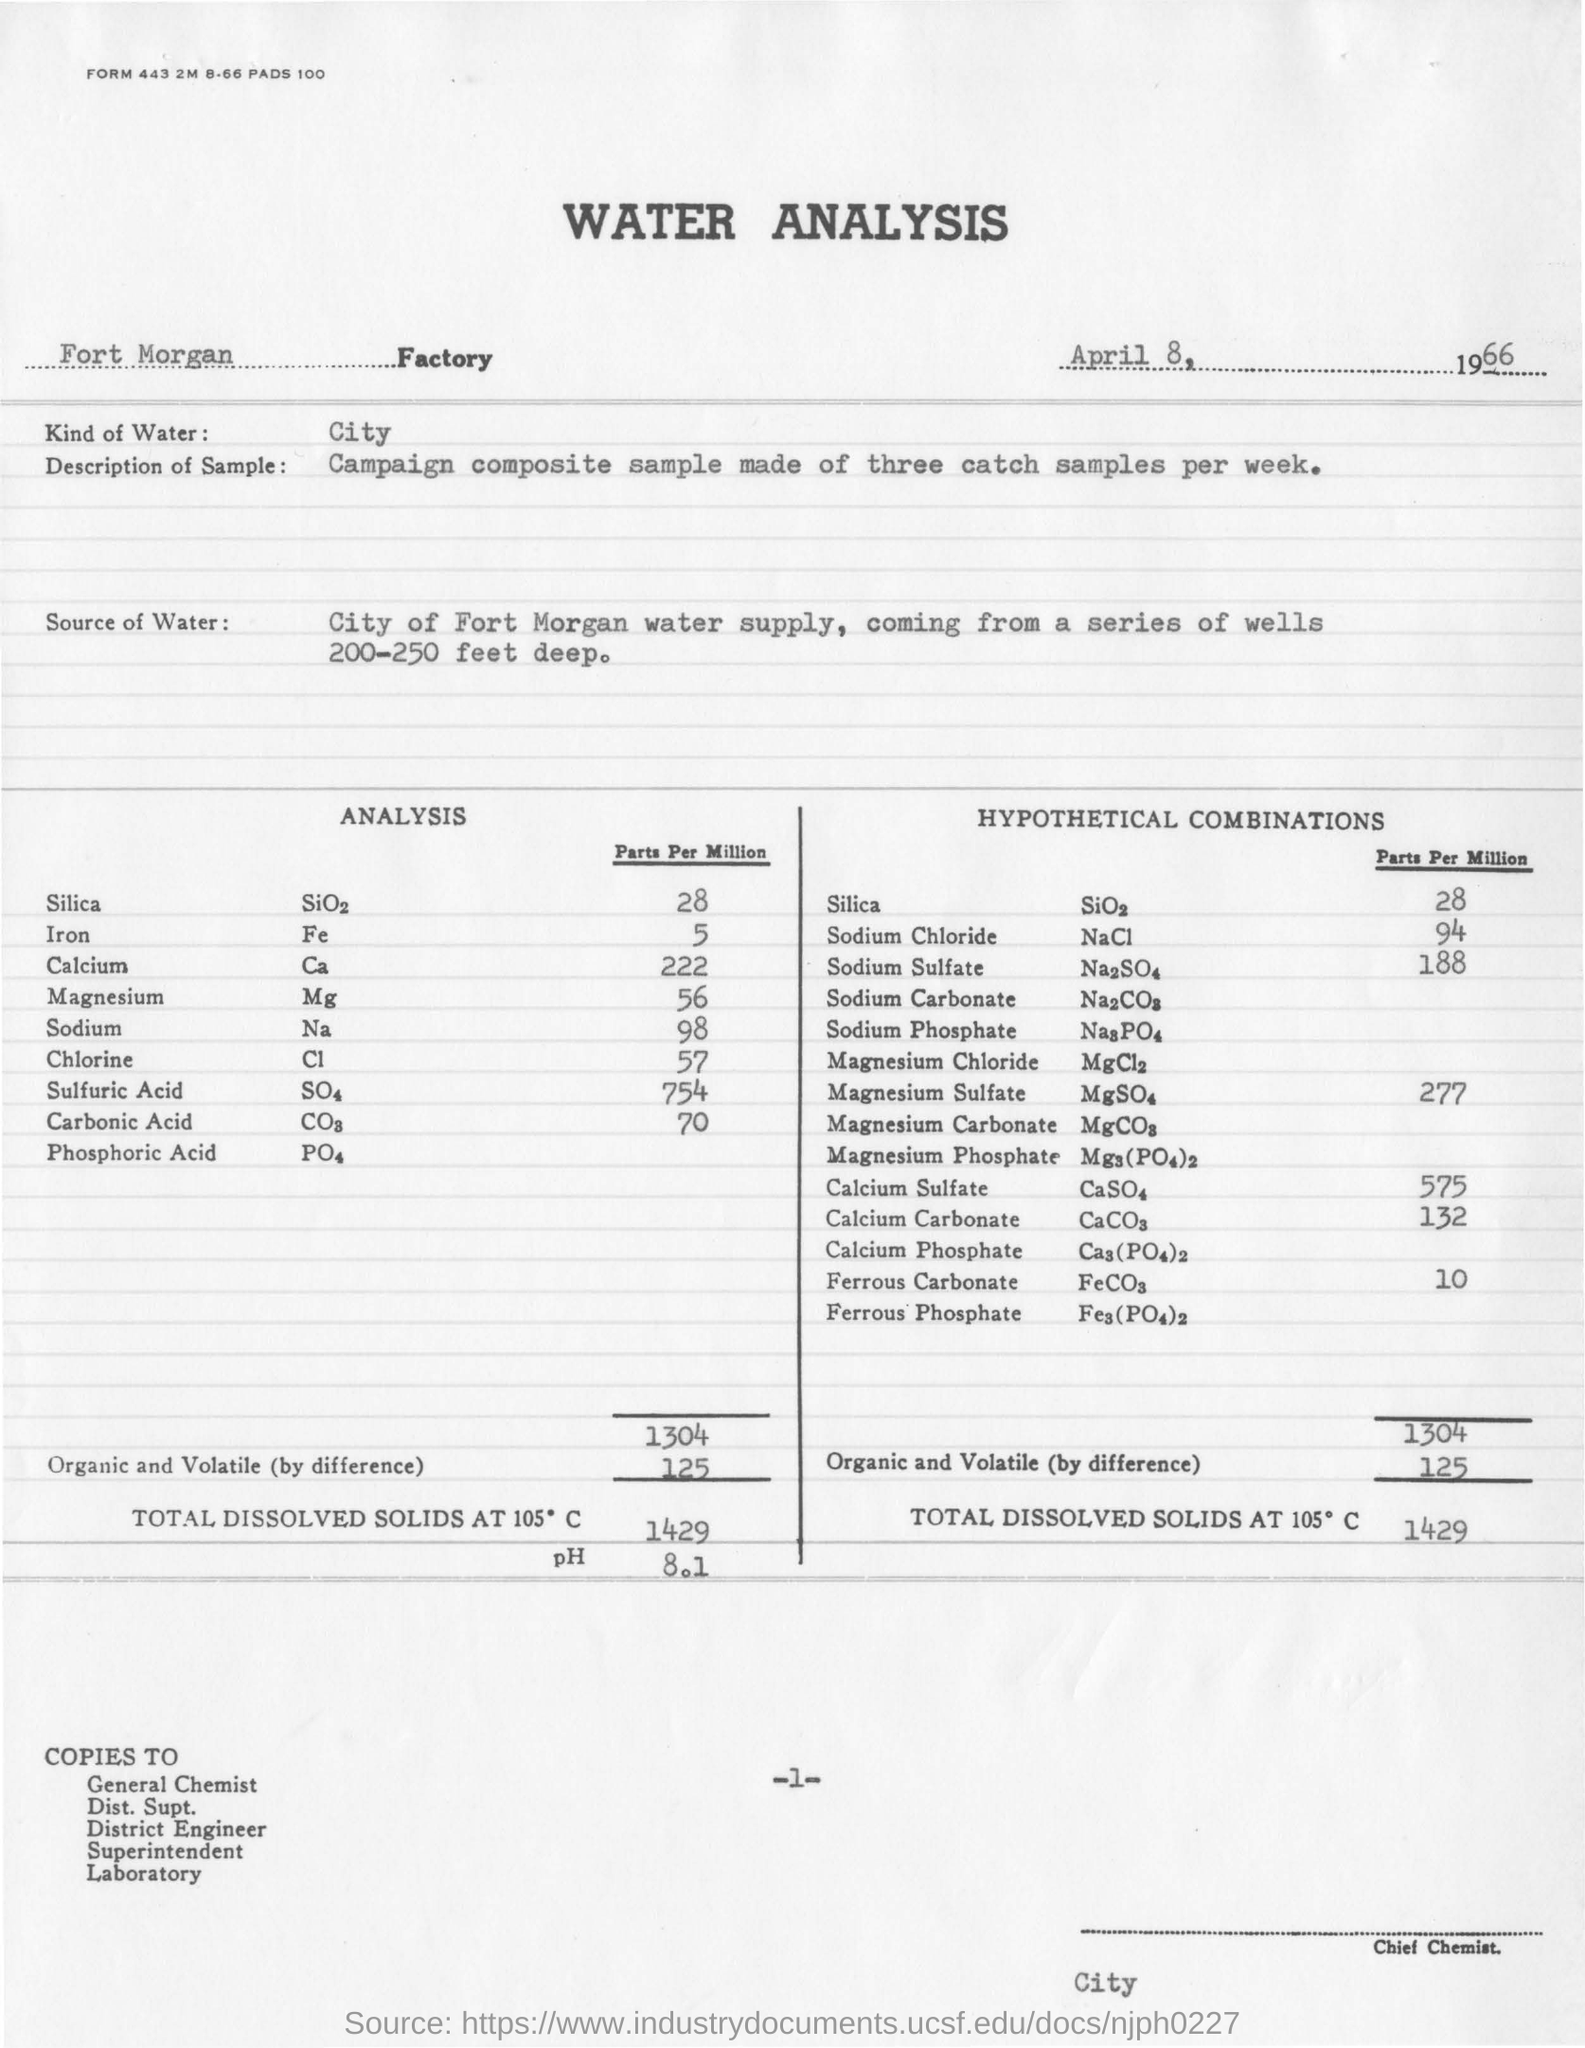What analysis is mentioned in this document?
Keep it short and to the point. WATER ANALYSIS. In which Factory, the analysis  is conducted?
Give a very brief answer. Fort morgan. What kind of water is used for analysis?
Keep it short and to the point. City. What is the description of sample taken?
Provide a short and direct response. Campaign composite sample made of three catch samples per week. What is the date mentioned in this document?
Offer a very short reply. April 8, 1966. What is the value of pH  in analysis?
Offer a terse response. 8 1. What is the quantity of Calcium(Parts per Million) obtained in analysis?
Make the answer very short. 222. What is the quantity of Sodium chloride(Parts per Million) in Hypothetical combinations?
Provide a short and direct response. 94. 